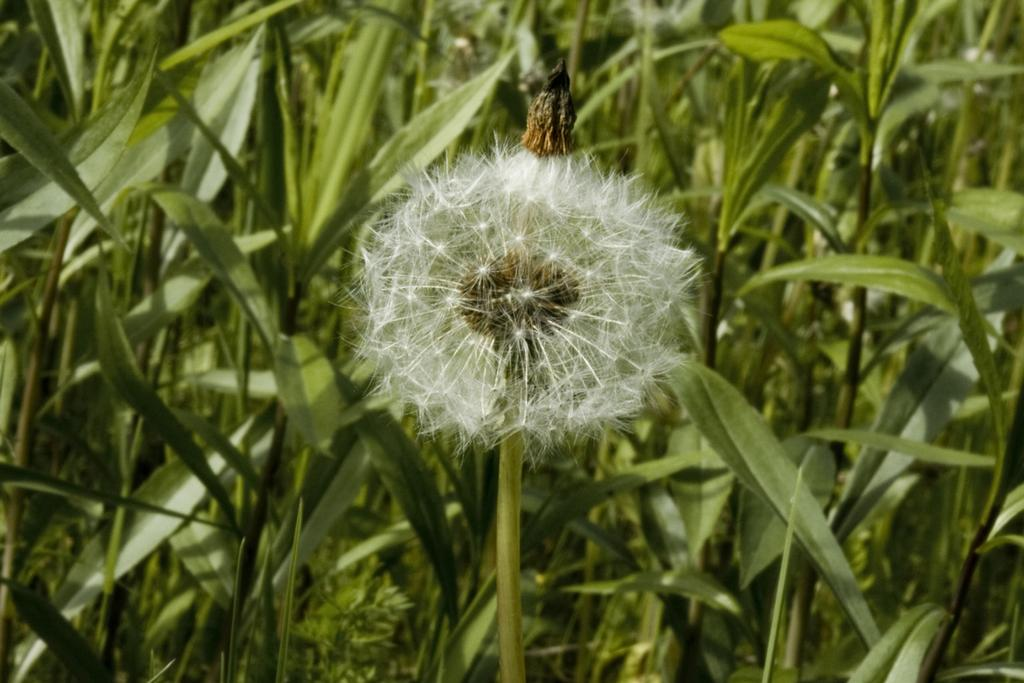What type of flower can be seen in the image? There is a white flower in the image. Where is the flower located? The flower is on a plant. What other plants are visible in the image? There are other plants with long leaves in the image. What type of soup is being served in the image? There is no soup present in the image; it features a white flower on a plant and other plants with long leaves. 